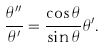Convert formula to latex. <formula><loc_0><loc_0><loc_500><loc_500>\frac { \theta ^ { \prime \prime } } { \theta ^ { \prime } } = \frac { \cos \theta } { \sin \theta } \theta ^ { \prime } .</formula> 